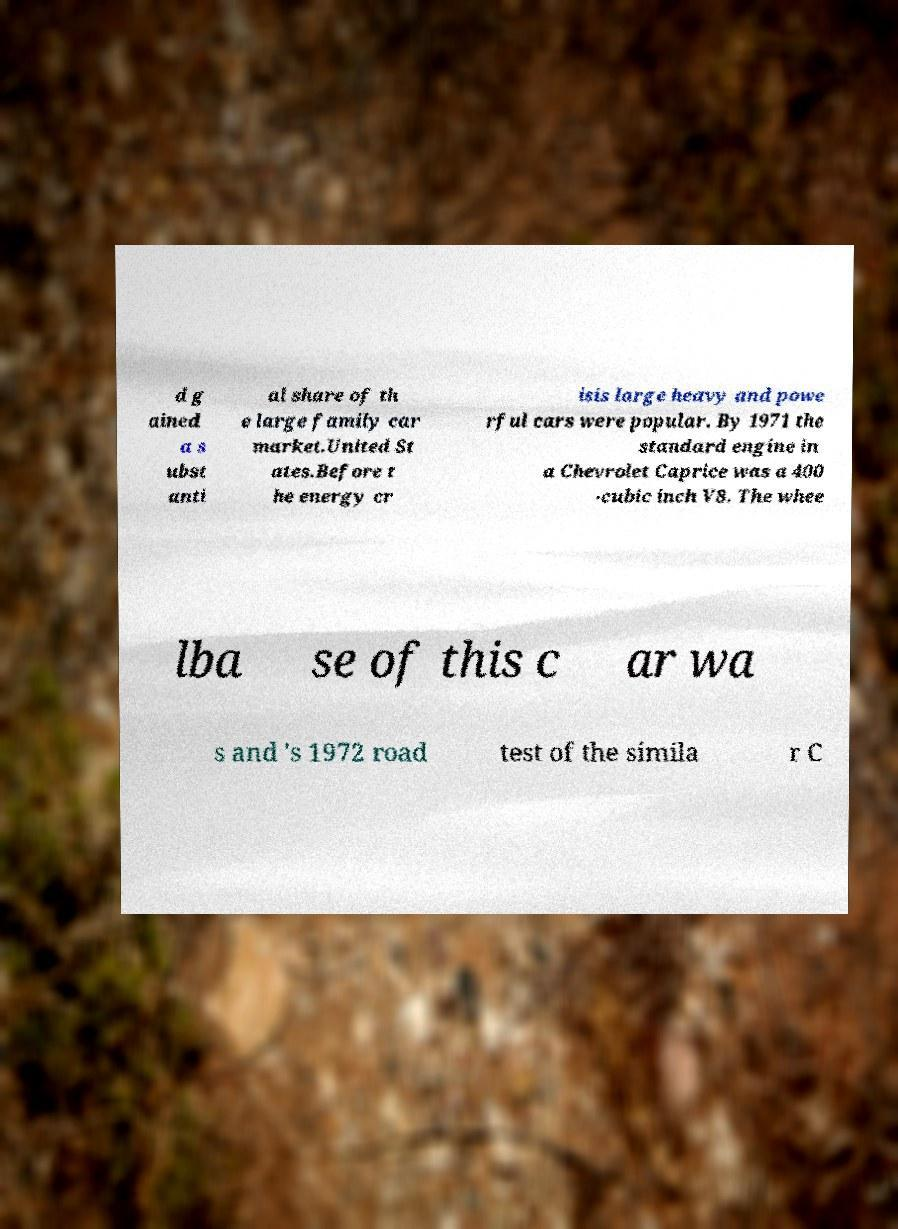Could you extract and type out the text from this image? d g ained a s ubst anti al share of th e large family car market.United St ates.Before t he energy cr isis large heavy and powe rful cars were popular. By 1971 the standard engine in a Chevrolet Caprice was a 400 -cubic inch V8. The whee lba se of this c ar wa s and 's 1972 road test of the simila r C 